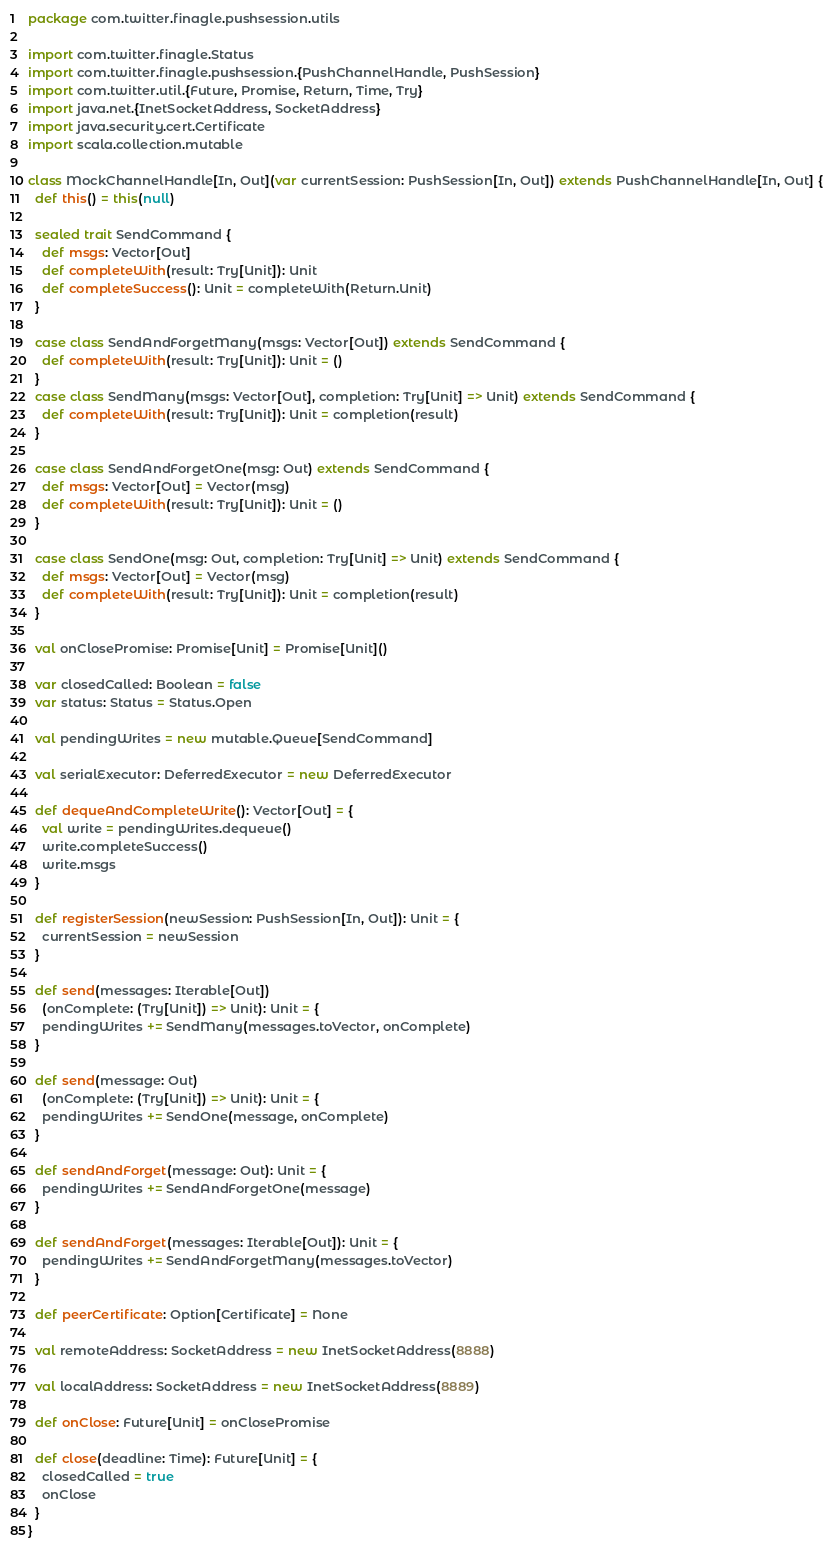Convert code to text. <code><loc_0><loc_0><loc_500><loc_500><_Scala_>package com.twitter.finagle.pushsession.utils

import com.twitter.finagle.Status
import com.twitter.finagle.pushsession.{PushChannelHandle, PushSession}
import com.twitter.util.{Future, Promise, Return, Time, Try}
import java.net.{InetSocketAddress, SocketAddress}
import java.security.cert.Certificate
import scala.collection.mutable

class MockChannelHandle[In, Out](var currentSession: PushSession[In, Out]) extends PushChannelHandle[In, Out] {
  def this() = this(null)

  sealed trait SendCommand {
    def msgs: Vector[Out]
    def completeWith(result: Try[Unit]): Unit
    def completeSuccess(): Unit = completeWith(Return.Unit)
  }

  case class SendAndForgetMany(msgs: Vector[Out]) extends SendCommand {
    def completeWith(result: Try[Unit]): Unit = ()
  }
  case class SendMany(msgs: Vector[Out], completion: Try[Unit] => Unit) extends SendCommand {
    def completeWith(result: Try[Unit]): Unit = completion(result)
  }

  case class SendAndForgetOne(msg: Out) extends SendCommand {
    def msgs: Vector[Out] = Vector(msg)
    def completeWith(result: Try[Unit]): Unit = ()
  }

  case class SendOne(msg: Out, completion: Try[Unit] => Unit) extends SendCommand {
    def msgs: Vector[Out] = Vector(msg)
    def completeWith(result: Try[Unit]): Unit = completion(result)
  }

  val onClosePromise: Promise[Unit] = Promise[Unit]()

  var closedCalled: Boolean = false
  var status: Status = Status.Open

  val pendingWrites = new mutable.Queue[SendCommand]

  val serialExecutor: DeferredExecutor = new DeferredExecutor

  def dequeAndCompleteWrite(): Vector[Out] = {
    val write = pendingWrites.dequeue()
    write.completeSuccess()
    write.msgs
  }

  def registerSession(newSession: PushSession[In, Out]): Unit = {
    currentSession = newSession
  }

  def send(messages: Iterable[Out])
    (onComplete: (Try[Unit]) => Unit): Unit = {
    pendingWrites += SendMany(messages.toVector, onComplete)
  }

  def send(message: Out)
    (onComplete: (Try[Unit]) => Unit): Unit = {
    pendingWrites += SendOne(message, onComplete)
  }

  def sendAndForget(message: Out): Unit = {
    pendingWrites += SendAndForgetOne(message)
  }

  def sendAndForget(messages: Iterable[Out]): Unit = {
    pendingWrites += SendAndForgetMany(messages.toVector)
  }

  def peerCertificate: Option[Certificate] = None

  val remoteAddress: SocketAddress = new InetSocketAddress(8888)

  val localAddress: SocketAddress = new InetSocketAddress(8889)

  def onClose: Future[Unit] = onClosePromise

  def close(deadline: Time): Future[Unit] = {
    closedCalled = true
    onClose
  }
}
</code> 